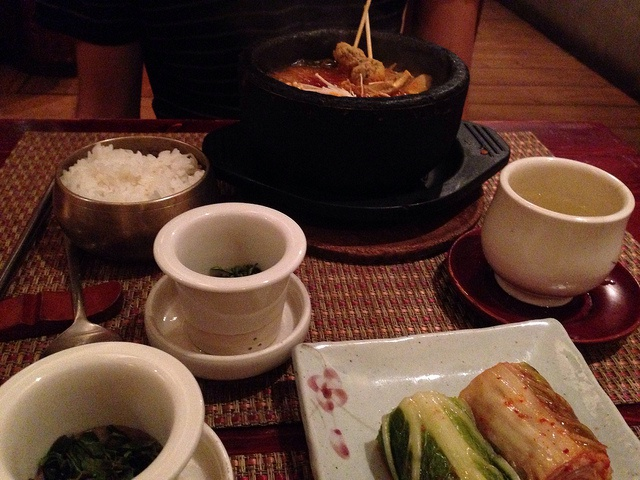Describe the objects in this image and their specific colors. I can see dining table in black, maroon, gray, brown, and tan tones, bowl in black, tan, and brown tones, bowl in black, maroon, and brown tones, people in black, maroon, and brown tones, and bowl in black, tan, maroon, and gray tones in this image. 